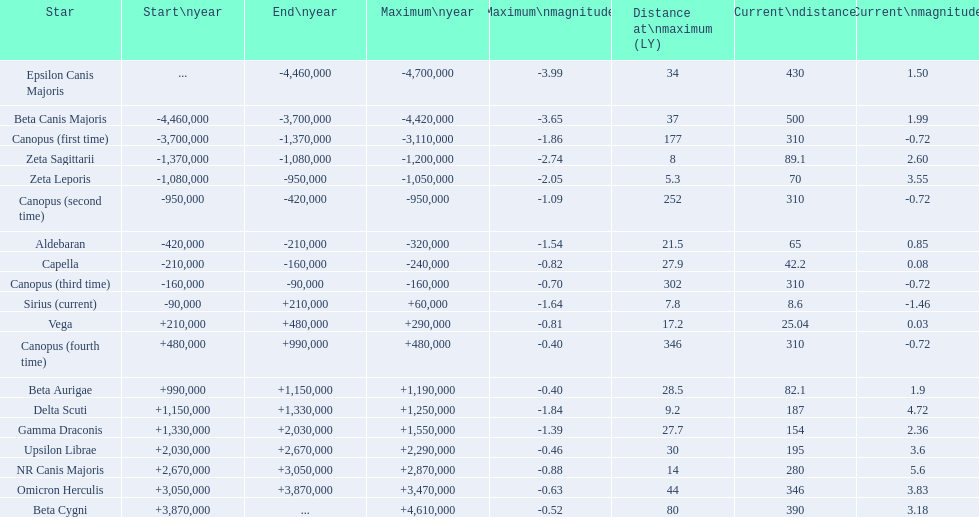What celestial object has a peak magnitude of -0.63? Omicron Herculis. Can you give me this table in json format? {'header': ['Star', 'Start\\nyear', 'End\\nyear', 'Maximum\\nyear', 'Maximum\\nmagnitude', 'Distance at\\nmaximum (LY)', 'Current\\ndistance', 'Current\\nmagnitude'], 'rows': [['Epsilon Canis Majoris', '...', '-4,460,000', '-4,700,000', '-3.99', '34', '430', '1.50'], ['Beta Canis Majoris', '-4,460,000', '-3,700,000', '-4,420,000', '-3.65', '37', '500', '1.99'], ['Canopus (first time)', '-3,700,000', '-1,370,000', '-3,110,000', '-1.86', '177', '310', '-0.72'], ['Zeta Sagittarii', '-1,370,000', '-1,080,000', '-1,200,000', '-2.74', '8', '89.1', '2.60'], ['Zeta Leporis', '-1,080,000', '-950,000', '-1,050,000', '-2.05', '5.3', '70', '3.55'], ['Canopus (second time)', '-950,000', '-420,000', '-950,000', '-1.09', '252', '310', '-0.72'], ['Aldebaran', '-420,000', '-210,000', '-320,000', '-1.54', '21.5', '65', '0.85'], ['Capella', '-210,000', '-160,000', '-240,000', '-0.82', '27.9', '42.2', '0.08'], ['Canopus (third time)', '-160,000', '-90,000', '-160,000', '-0.70', '302', '310', '-0.72'], ['Sirius (current)', '-90,000', '+210,000', '+60,000', '-1.64', '7.8', '8.6', '-1.46'], ['Vega', '+210,000', '+480,000', '+290,000', '-0.81', '17.2', '25.04', '0.03'], ['Canopus (fourth time)', '+480,000', '+990,000', '+480,000', '-0.40', '346', '310', '-0.72'], ['Beta Aurigae', '+990,000', '+1,150,000', '+1,190,000', '-0.40', '28.5', '82.1', '1.9'], ['Delta Scuti', '+1,150,000', '+1,330,000', '+1,250,000', '-1.84', '9.2', '187', '4.72'], ['Gamma Draconis', '+1,330,000', '+2,030,000', '+1,550,000', '-1.39', '27.7', '154', '2.36'], ['Upsilon Librae', '+2,030,000', '+2,670,000', '+2,290,000', '-0.46', '30', '195', '3.6'], ['NR Canis Majoris', '+2,670,000', '+3,050,000', '+2,870,000', '-0.88', '14', '280', '5.6'], ['Omicron Herculis', '+3,050,000', '+3,870,000', '+3,470,000', '-0.63', '44', '346', '3.83'], ['Beta Cygni', '+3,870,000', '...', '+4,610,000', '-0.52', '80', '390', '3.18']]} What celestial object has a current separation of 390? Beta Cygni. 